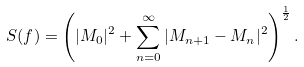<formula> <loc_0><loc_0><loc_500><loc_500>S ( f ) = \left ( | M _ { 0 } | ^ { 2 } + \sum _ { n = 0 } ^ { \infty } | M _ { n + 1 } - M _ { n } | ^ { 2 } \right ) ^ { \frac { 1 } { 2 } } .</formula> 